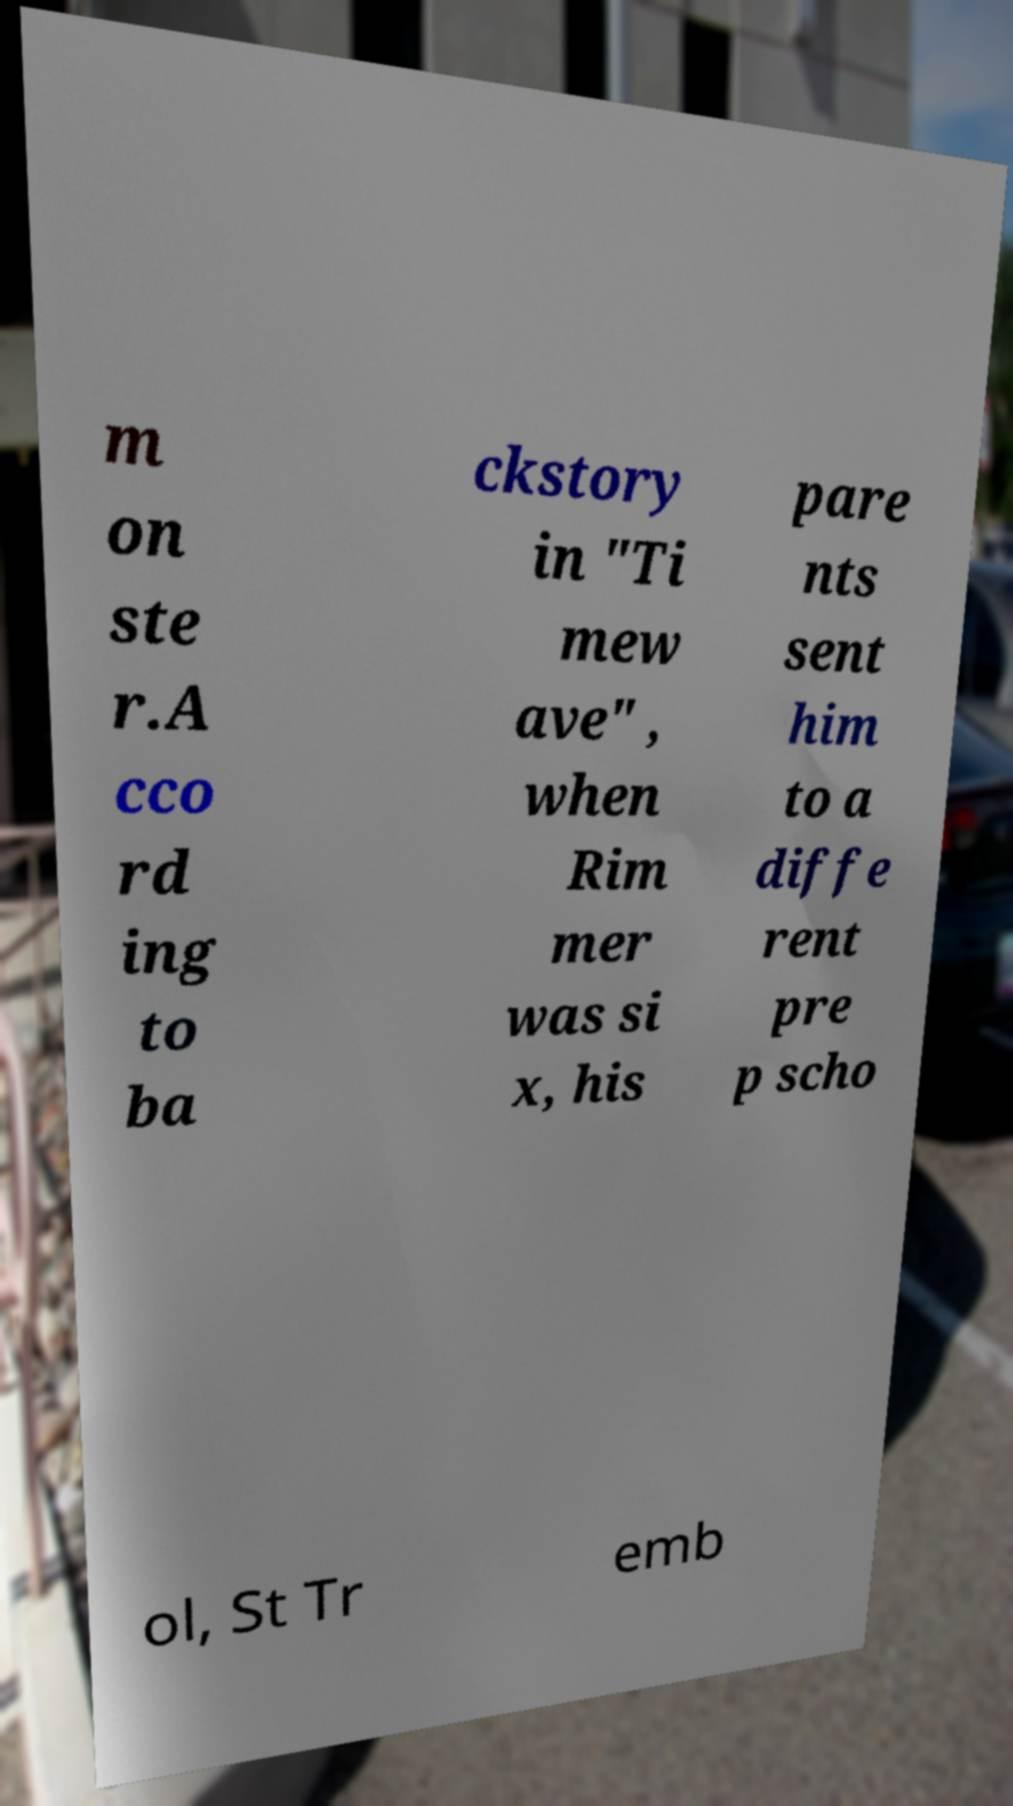Can you read and provide the text displayed in the image?This photo seems to have some interesting text. Can you extract and type it out for me? m on ste r.A cco rd ing to ba ckstory in "Ti mew ave" , when Rim mer was si x, his pare nts sent him to a diffe rent pre p scho ol, St Tr emb 